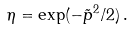<formula> <loc_0><loc_0><loc_500><loc_500>\eta = \exp ( - \tilde { p } ^ { 2 } / 2 ) \, .</formula> 